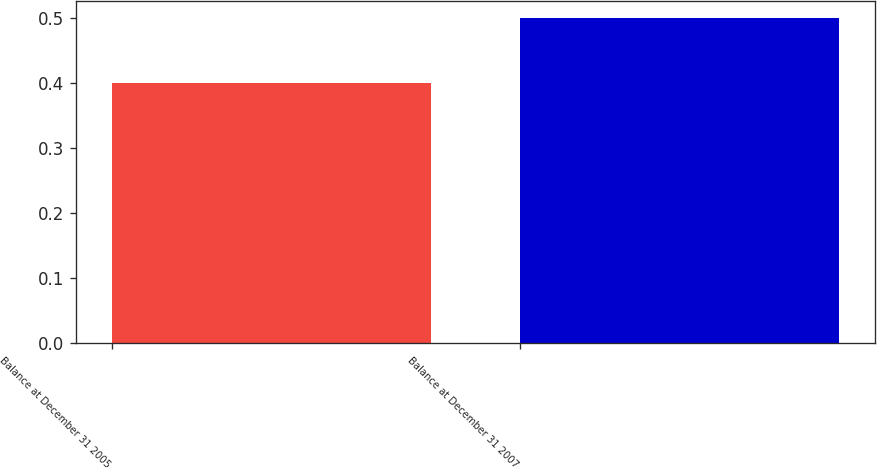Convert chart to OTSL. <chart><loc_0><loc_0><loc_500><loc_500><bar_chart><fcel>Balance at December 31 2005<fcel>Balance at December 31 2007<nl><fcel>0.4<fcel>0.5<nl></chart> 